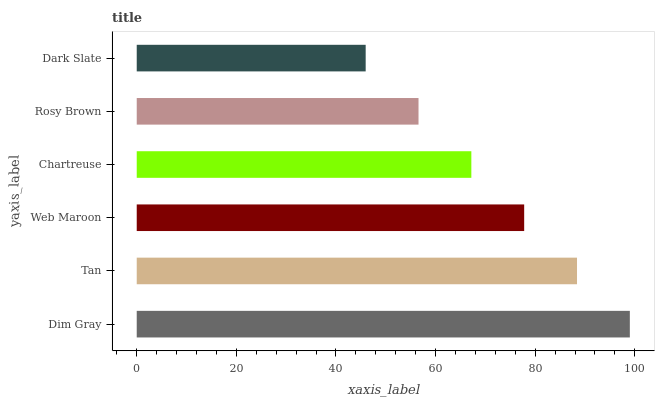Is Dark Slate the minimum?
Answer yes or no. Yes. Is Dim Gray the maximum?
Answer yes or no. Yes. Is Tan the minimum?
Answer yes or no. No. Is Tan the maximum?
Answer yes or no. No. Is Dim Gray greater than Tan?
Answer yes or no. Yes. Is Tan less than Dim Gray?
Answer yes or no. Yes. Is Tan greater than Dim Gray?
Answer yes or no. No. Is Dim Gray less than Tan?
Answer yes or no. No. Is Web Maroon the high median?
Answer yes or no. Yes. Is Chartreuse the low median?
Answer yes or no. Yes. Is Dim Gray the high median?
Answer yes or no. No. Is Dim Gray the low median?
Answer yes or no. No. 